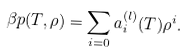Convert formula to latex. <formula><loc_0><loc_0><loc_500><loc_500>\beta p ( T , \rho ) = \sum _ { i = 0 } a _ { i } ^ { ( l ) } ( T ) \rho ^ { i } .</formula> 